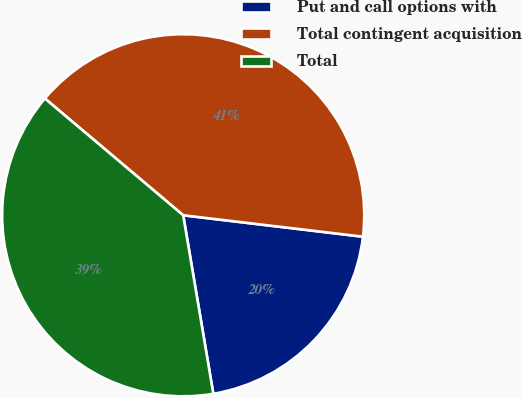<chart> <loc_0><loc_0><loc_500><loc_500><pie_chart><fcel>Put and call options with<fcel>Total contingent acquisition<fcel>Total<nl><fcel>20.45%<fcel>40.73%<fcel>38.82%<nl></chart> 